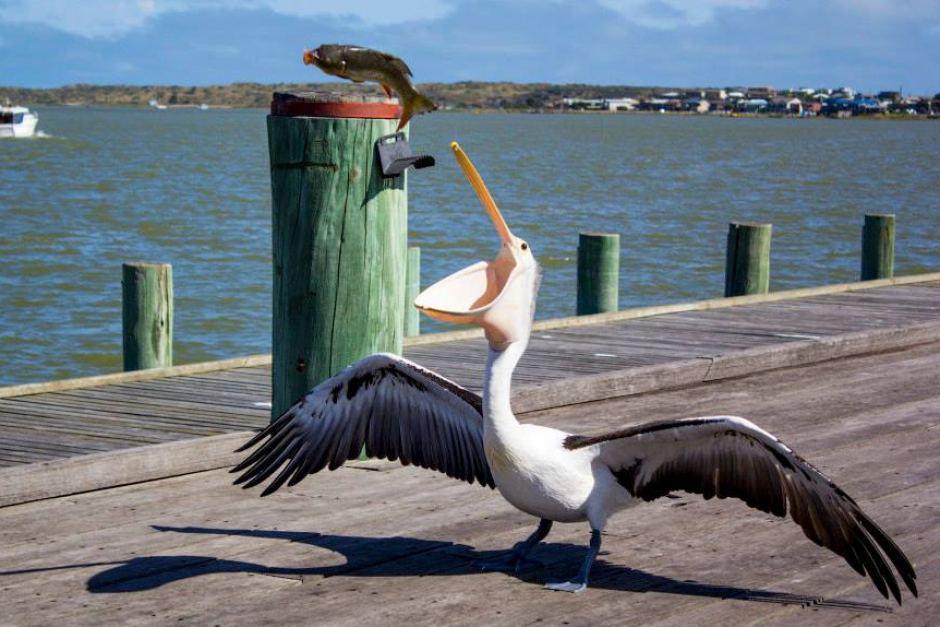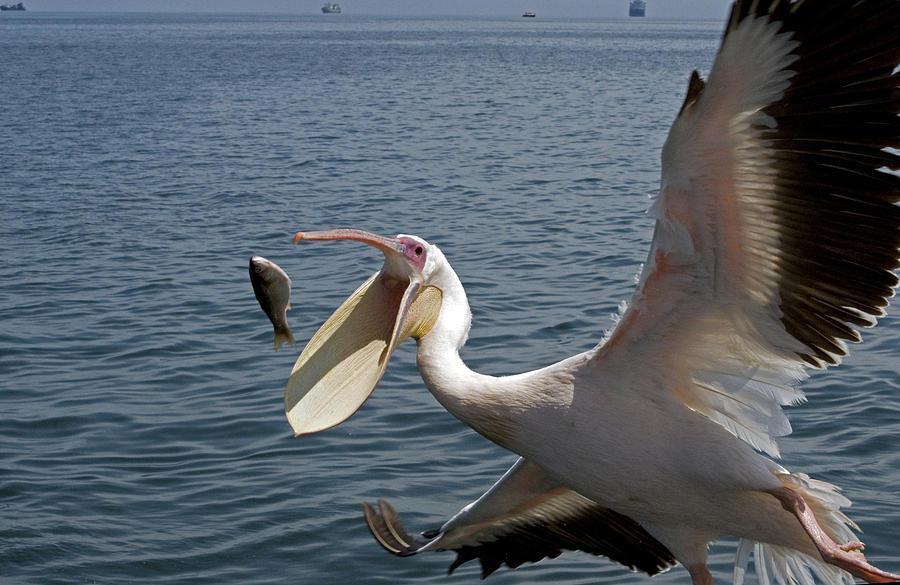The first image is the image on the left, the second image is the image on the right. Considering the images on both sides, is "The bird on the left has a fish, but there are no fish in the right image." valid? Answer yes or no. No. 